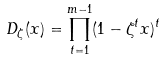<formula> <loc_0><loc_0><loc_500><loc_500>D _ { \zeta } ( x ) = \prod _ { t = 1 } ^ { m - 1 } ( 1 - \zeta ^ { t } x ) ^ { t }</formula> 